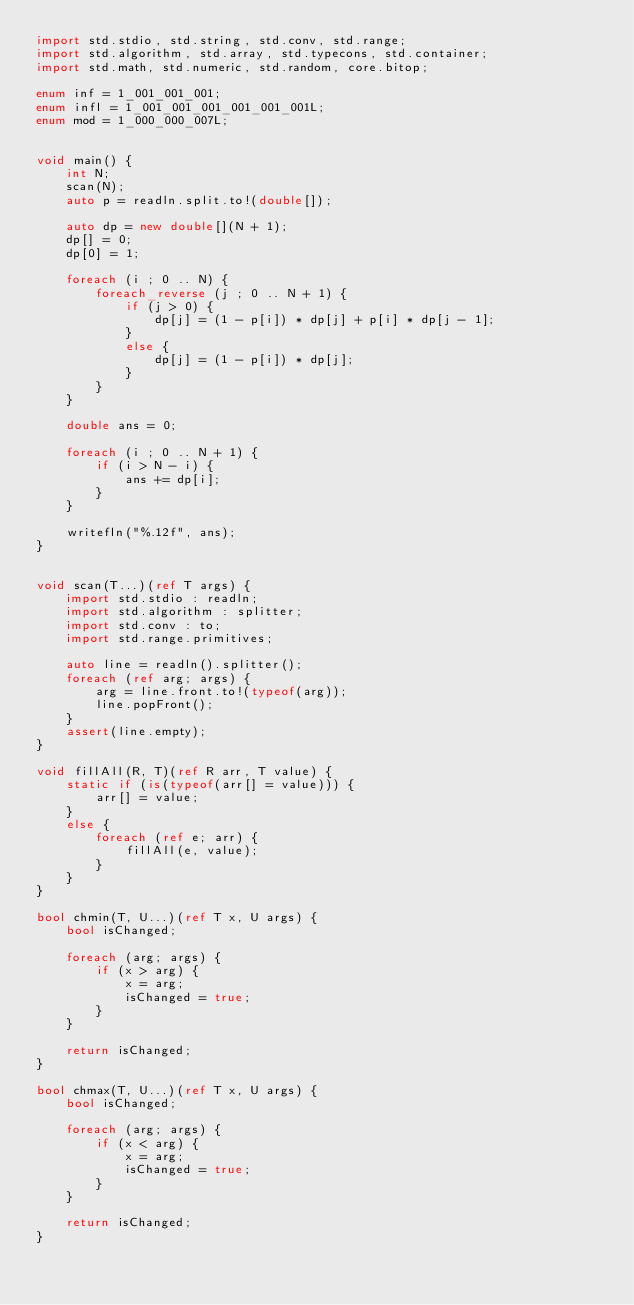Convert code to text. <code><loc_0><loc_0><loc_500><loc_500><_D_>import std.stdio, std.string, std.conv, std.range;
import std.algorithm, std.array, std.typecons, std.container;
import std.math, std.numeric, std.random, core.bitop;

enum inf = 1_001_001_001;
enum infl = 1_001_001_001_001_001_001L;
enum mod = 1_000_000_007L;


void main() {
    int N;
    scan(N);
    auto p = readln.split.to!(double[]);

    auto dp = new double[](N + 1);
    dp[] = 0;
    dp[0] = 1;

    foreach (i ; 0 .. N) {
        foreach_reverse (j ; 0 .. N + 1) {
            if (j > 0) {
                dp[j] = (1 - p[i]) * dp[j] + p[i] * dp[j - 1];
            }
            else {
                dp[j] = (1 - p[i]) * dp[j];
            }
        }
    }

    double ans = 0;

    foreach (i ; 0 .. N + 1) {
        if (i > N - i) {
            ans += dp[i];
        }
    }

    writefln("%.12f", ans);
}


void scan(T...)(ref T args) {
    import std.stdio : readln;
    import std.algorithm : splitter;
    import std.conv : to;
    import std.range.primitives;

    auto line = readln().splitter();
    foreach (ref arg; args) {
        arg = line.front.to!(typeof(arg));
        line.popFront();
    }
    assert(line.empty);
}

void fillAll(R, T)(ref R arr, T value) {
    static if (is(typeof(arr[] = value))) {
        arr[] = value;
    }
    else {
        foreach (ref e; arr) {
            fillAll(e, value);
        }
    }
}

bool chmin(T, U...)(ref T x, U args) {
    bool isChanged;

    foreach (arg; args) {
        if (x > arg) {
            x = arg;
            isChanged = true;
        }
    }

    return isChanged;
}

bool chmax(T, U...)(ref T x, U args) {
    bool isChanged;

    foreach (arg; args) {
        if (x < arg) {
            x = arg;
            isChanged = true;
        }
    }

    return isChanged;
}
</code> 